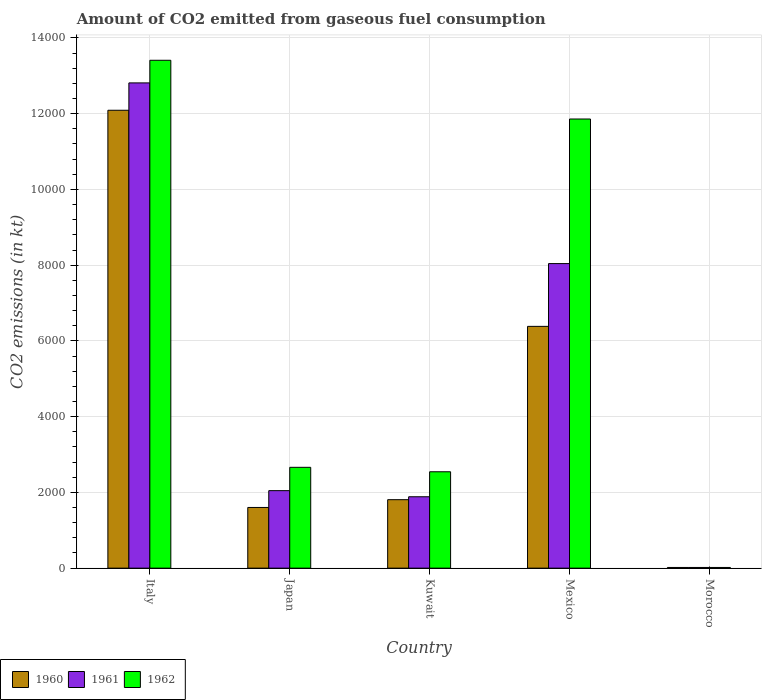How many groups of bars are there?
Keep it short and to the point. 5. Are the number of bars per tick equal to the number of legend labels?
Offer a terse response. Yes. How many bars are there on the 3rd tick from the right?
Give a very brief answer. 3. What is the label of the 1st group of bars from the left?
Make the answer very short. Italy. In how many cases, is the number of bars for a given country not equal to the number of legend labels?
Offer a very short reply. 0. What is the amount of CO2 emitted in 1962 in Kuwait?
Give a very brief answer. 2544.9. Across all countries, what is the maximum amount of CO2 emitted in 1960?
Ensure brevity in your answer.  1.21e+04. Across all countries, what is the minimum amount of CO2 emitted in 1962?
Provide a succinct answer. 18.34. In which country was the amount of CO2 emitted in 1960 minimum?
Keep it short and to the point. Morocco. What is the total amount of CO2 emitted in 1962 in the graph?
Offer a very short reply. 3.05e+04. What is the difference between the amount of CO2 emitted in 1962 in Kuwait and that in Mexico?
Offer a terse response. -9314.18. What is the difference between the amount of CO2 emitted in 1961 in Mexico and the amount of CO2 emitted in 1962 in Morocco?
Your answer should be very brief. 8023.4. What is the average amount of CO2 emitted in 1962 per country?
Provide a succinct answer. 6098.95. What is the difference between the amount of CO2 emitted of/in 1962 and amount of CO2 emitted of/in 1961 in Mexico?
Your answer should be compact. 3817.35. What is the ratio of the amount of CO2 emitted in 1960 in Italy to that in Japan?
Offer a very short reply. 7.54. Is the amount of CO2 emitted in 1960 in Kuwait less than that in Mexico?
Your answer should be compact. Yes. Is the difference between the amount of CO2 emitted in 1962 in Kuwait and Mexico greater than the difference between the amount of CO2 emitted in 1961 in Kuwait and Mexico?
Give a very brief answer. No. What is the difference between the highest and the second highest amount of CO2 emitted in 1960?
Ensure brevity in your answer.  -5705.85. What is the difference between the highest and the lowest amount of CO2 emitted in 1962?
Offer a terse response. 1.34e+04. What does the 3rd bar from the left in Mexico represents?
Offer a terse response. 1962. Is it the case that in every country, the sum of the amount of CO2 emitted in 1962 and amount of CO2 emitted in 1961 is greater than the amount of CO2 emitted in 1960?
Offer a very short reply. Yes. Are the values on the major ticks of Y-axis written in scientific E-notation?
Ensure brevity in your answer.  No. Does the graph contain any zero values?
Give a very brief answer. No. How many legend labels are there?
Ensure brevity in your answer.  3. How are the legend labels stacked?
Your answer should be compact. Horizontal. What is the title of the graph?
Provide a succinct answer. Amount of CO2 emitted from gaseous fuel consumption. Does "1997" appear as one of the legend labels in the graph?
Provide a short and direct response. No. What is the label or title of the X-axis?
Your response must be concise. Country. What is the label or title of the Y-axis?
Provide a succinct answer. CO2 emissions (in kt). What is the CO2 emissions (in kt) in 1960 in Italy?
Provide a short and direct response. 1.21e+04. What is the CO2 emissions (in kt) in 1961 in Italy?
Your answer should be very brief. 1.28e+04. What is the CO2 emissions (in kt) in 1962 in Italy?
Your answer should be very brief. 1.34e+04. What is the CO2 emissions (in kt) of 1960 in Japan?
Ensure brevity in your answer.  1602.48. What is the CO2 emissions (in kt) of 1961 in Japan?
Offer a terse response. 2046.19. What is the CO2 emissions (in kt) of 1962 in Japan?
Offer a terse response. 2662.24. What is the CO2 emissions (in kt) of 1960 in Kuwait?
Give a very brief answer. 1807.83. What is the CO2 emissions (in kt) of 1961 in Kuwait?
Your response must be concise. 1884.84. What is the CO2 emissions (in kt) of 1962 in Kuwait?
Your answer should be very brief. 2544.9. What is the CO2 emissions (in kt) of 1960 in Mexico?
Provide a succinct answer. 6384.25. What is the CO2 emissions (in kt) of 1961 in Mexico?
Keep it short and to the point. 8041.73. What is the CO2 emissions (in kt) of 1962 in Mexico?
Your answer should be compact. 1.19e+04. What is the CO2 emissions (in kt) in 1960 in Morocco?
Offer a terse response. 18.34. What is the CO2 emissions (in kt) in 1961 in Morocco?
Provide a short and direct response. 18.34. What is the CO2 emissions (in kt) of 1962 in Morocco?
Provide a short and direct response. 18.34. Across all countries, what is the maximum CO2 emissions (in kt) in 1960?
Provide a succinct answer. 1.21e+04. Across all countries, what is the maximum CO2 emissions (in kt) of 1961?
Your answer should be very brief. 1.28e+04. Across all countries, what is the maximum CO2 emissions (in kt) in 1962?
Your answer should be compact. 1.34e+04. Across all countries, what is the minimum CO2 emissions (in kt) of 1960?
Keep it short and to the point. 18.34. Across all countries, what is the minimum CO2 emissions (in kt) in 1961?
Your answer should be compact. 18.34. Across all countries, what is the minimum CO2 emissions (in kt) in 1962?
Provide a succinct answer. 18.34. What is the total CO2 emissions (in kt) in 1960 in the graph?
Your answer should be compact. 2.19e+04. What is the total CO2 emissions (in kt) of 1961 in the graph?
Provide a short and direct response. 2.48e+04. What is the total CO2 emissions (in kt) in 1962 in the graph?
Your answer should be very brief. 3.05e+04. What is the difference between the CO2 emissions (in kt) in 1960 in Italy and that in Japan?
Offer a very short reply. 1.05e+04. What is the difference between the CO2 emissions (in kt) in 1961 in Italy and that in Japan?
Offer a very short reply. 1.08e+04. What is the difference between the CO2 emissions (in kt) in 1962 in Italy and that in Japan?
Ensure brevity in your answer.  1.07e+04. What is the difference between the CO2 emissions (in kt) in 1960 in Italy and that in Kuwait?
Make the answer very short. 1.03e+04. What is the difference between the CO2 emissions (in kt) of 1961 in Italy and that in Kuwait?
Keep it short and to the point. 1.09e+04. What is the difference between the CO2 emissions (in kt) in 1962 in Italy and that in Kuwait?
Provide a short and direct response. 1.09e+04. What is the difference between the CO2 emissions (in kt) in 1960 in Italy and that in Mexico?
Ensure brevity in your answer.  5705.85. What is the difference between the CO2 emissions (in kt) in 1961 in Italy and that in Mexico?
Your response must be concise. 4770.77. What is the difference between the CO2 emissions (in kt) in 1962 in Italy and that in Mexico?
Your response must be concise. 1551.14. What is the difference between the CO2 emissions (in kt) of 1960 in Italy and that in Morocco?
Make the answer very short. 1.21e+04. What is the difference between the CO2 emissions (in kt) in 1961 in Italy and that in Morocco?
Your answer should be compact. 1.28e+04. What is the difference between the CO2 emissions (in kt) of 1962 in Italy and that in Morocco?
Give a very brief answer. 1.34e+04. What is the difference between the CO2 emissions (in kt) of 1960 in Japan and that in Kuwait?
Offer a terse response. -205.35. What is the difference between the CO2 emissions (in kt) in 1961 in Japan and that in Kuwait?
Keep it short and to the point. 161.35. What is the difference between the CO2 emissions (in kt) in 1962 in Japan and that in Kuwait?
Make the answer very short. 117.34. What is the difference between the CO2 emissions (in kt) in 1960 in Japan and that in Mexico?
Offer a very short reply. -4781.77. What is the difference between the CO2 emissions (in kt) in 1961 in Japan and that in Mexico?
Provide a short and direct response. -5995.55. What is the difference between the CO2 emissions (in kt) in 1962 in Japan and that in Mexico?
Give a very brief answer. -9196.84. What is the difference between the CO2 emissions (in kt) of 1960 in Japan and that in Morocco?
Offer a very short reply. 1584.14. What is the difference between the CO2 emissions (in kt) in 1961 in Japan and that in Morocco?
Offer a very short reply. 2027.85. What is the difference between the CO2 emissions (in kt) in 1962 in Japan and that in Morocco?
Provide a succinct answer. 2643.91. What is the difference between the CO2 emissions (in kt) in 1960 in Kuwait and that in Mexico?
Keep it short and to the point. -4576.42. What is the difference between the CO2 emissions (in kt) in 1961 in Kuwait and that in Mexico?
Your response must be concise. -6156.89. What is the difference between the CO2 emissions (in kt) in 1962 in Kuwait and that in Mexico?
Your answer should be compact. -9314.18. What is the difference between the CO2 emissions (in kt) in 1960 in Kuwait and that in Morocco?
Provide a succinct answer. 1789.5. What is the difference between the CO2 emissions (in kt) of 1961 in Kuwait and that in Morocco?
Offer a terse response. 1866.5. What is the difference between the CO2 emissions (in kt) in 1962 in Kuwait and that in Morocco?
Offer a very short reply. 2526.56. What is the difference between the CO2 emissions (in kt) of 1960 in Mexico and that in Morocco?
Your response must be concise. 6365.91. What is the difference between the CO2 emissions (in kt) in 1961 in Mexico and that in Morocco?
Your answer should be very brief. 8023.4. What is the difference between the CO2 emissions (in kt) in 1962 in Mexico and that in Morocco?
Make the answer very short. 1.18e+04. What is the difference between the CO2 emissions (in kt) of 1960 in Italy and the CO2 emissions (in kt) of 1961 in Japan?
Your response must be concise. 1.00e+04. What is the difference between the CO2 emissions (in kt) of 1960 in Italy and the CO2 emissions (in kt) of 1962 in Japan?
Offer a very short reply. 9427.86. What is the difference between the CO2 emissions (in kt) in 1961 in Italy and the CO2 emissions (in kt) in 1962 in Japan?
Provide a short and direct response. 1.02e+04. What is the difference between the CO2 emissions (in kt) in 1960 in Italy and the CO2 emissions (in kt) in 1961 in Kuwait?
Offer a very short reply. 1.02e+04. What is the difference between the CO2 emissions (in kt) in 1960 in Italy and the CO2 emissions (in kt) in 1962 in Kuwait?
Keep it short and to the point. 9545.2. What is the difference between the CO2 emissions (in kt) in 1961 in Italy and the CO2 emissions (in kt) in 1962 in Kuwait?
Your answer should be compact. 1.03e+04. What is the difference between the CO2 emissions (in kt) in 1960 in Italy and the CO2 emissions (in kt) in 1961 in Mexico?
Ensure brevity in your answer.  4048.37. What is the difference between the CO2 emissions (in kt) in 1960 in Italy and the CO2 emissions (in kt) in 1962 in Mexico?
Your response must be concise. 231.02. What is the difference between the CO2 emissions (in kt) of 1961 in Italy and the CO2 emissions (in kt) of 1962 in Mexico?
Your answer should be very brief. 953.42. What is the difference between the CO2 emissions (in kt) in 1960 in Italy and the CO2 emissions (in kt) in 1961 in Morocco?
Offer a very short reply. 1.21e+04. What is the difference between the CO2 emissions (in kt) of 1960 in Italy and the CO2 emissions (in kt) of 1962 in Morocco?
Your response must be concise. 1.21e+04. What is the difference between the CO2 emissions (in kt) in 1961 in Italy and the CO2 emissions (in kt) in 1962 in Morocco?
Make the answer very short. 1.28e+04. What is the difference between the CO2 emissions (in kt) in 1960 in Japan and the CO2 emissions (in kt) in 1961 in Kuwait?
Your answer should be very brief. -282.36. What is the difference between the CO2 emissions (in kt) of 1960 in Japan and the CO2 emissions (in kt) of 1962 in Kuwait?
Ensure brevity in your answer.  -942.42. What is the difference between the CO2 emissions (in kt) in 1961 in Japan and the CO2 emissions (in kt) in 1962 in Kuwait?
Provide a short and direct response. -498.71. What is the difference between the CO2 emissions (in kt) of 1960 in Japan and the CO2 emissions (in kt) of 1961 in Mexico?
Give a very brief answer. -6439.25. What is the difference between the CO2 emissions (in kt) of 1960 in Japan and the CO2 emissions (in kt) of 1962 in Mexico?
Ensure brevity in your answer.  -1.03e+04. What is the difference between the CO2 emissions (in kt) of 1961 in Japan and the CO2 emissions (in kt) of 1962 in Mexico?
Your answer should be compact. -9812.89. What is the difference between the CO2 emissions (in kt) in 1960 in Japan and the CO2 emissions (in kt) in 1961 in Morocco?
Provide a short and direct response. 1584.14. What is the difference between the CO2 emissions (in kt) in 1960 in Japan and the CO2 emissions (in kt) in 1962 in Morocco?
Your answer should be very brief. 1584.14. What is the difference between the CO2 emissions (in kt) in 1961 in Japan and the CO2 emissions (in kt) in 1962 in Morocco?
Your response must be concise. 2027.85. What is the difference between the CO2 emissions (in kt) in 1960 in Kuwait and the CO2 emissions (in kt) in 1961 in Mexico?
Your answer should be very brief. -6233.9. What is the difference between the CO2 emissions (in kt) in 1960 in Kuwait and the CO2 emissions (in kt) in 1962 in Mexico?
Make the answer very short. -1.01e+04. What is the difference between the CO2 emissions (in kt) of 1961 in Kuwait and the CO2 emissions (in kt) of 1962 in Mexico?
Give a very brief answer. -9974.24. What is the difference between the CO2 emissions (in kt) in 1960 in Kuwait and the CO2 emissions (in kt) in 1961 in Morocco?
Offer a terse response. 1789.5. What is the difference between the CO2 emissions (in kt) in 1960 in Kuwait and the CO2 emissions (in kt) in 1962 in Morocco?
Give a very brief answer. 1789.5. What is the difference between the CO2 emissions (in kt) of 1961 in Kuwait and the CO2 emissions (in kt) of 1962 in Morocco?
Your answer should be very brief. 1866.5. What is the difference between the CO2 emissions (in kt) of 1960 in Mexico and the CO2 emissions (in kt) of 1961 in Morocco?
Your response must be concise. 6365.91. What is the difference between the CO2 emissions (in kt) of 1960 in Mexico and the CO2 emissions (in kt) of 1962 in Morocco?
Your response must be concise. 6365.91. What is the difference between the CO2 emissions (in kt) of 1961 in Mexico and the CO2 emissions (in kt) of 1962 in Morocco?
Make the answer very short. 8023.4. What is the average CO2 emissions (in kt) in 1960 per country?
Keep it short and to the point. 4380.6. What is the average CO2 emissions (in kt) of 1961 per country?
Offer a terse response. 4960.72. What is the average CO2 emissions (in kt) of 1962 per country?
Ensure brevity in your answer.  6098.95. What is the difference between the CO2 emissions (in kt) of 1960 and CO2 emissions (in kt) of 1961 in Italy?
Keep it short and to the point. -722.4. What is the difference between the CO2 emissions (in kt) of 1960 and CO2 emissions (in kt) of 1962 in Italy?
Offer a very short reply. -1320.12. What is the difference between the CO2 emissions (in kt) of 1961 and CO2 emissions (in kt) of 1962 in Italy?
Your answer should be compact. -597.72. What is the difference between the CO2 emissions (in kt) of 1960 and CO2 emissions (in kt) of 1961 in Japan?
Your answer should be very brief. -443.71. What is the difference between the CO2 emissions (in kt) in 1960 and CO2 emissions (in kt) in 1962 in Japan?
Your answer should be compact. -1059.76. What is the difference between the CO2 emissions (in kt) in 1961 and CO2 emissions (in kt) in 1962 in Japan?
Your response must be concise. -616.06. What is the difference between the CO2 emissions (in kt) in 1960 and CO2 emissions (in kt) in 1961 in Kuwait?
Provide a short and direct response. -77.01. What is the difference between the CO2 emissions (in kt) in 1960 and CO2 emissions (in kt) in 1962 in Kuwait?
Offer a very short reply. -737.07. What is the difference between the CO2 emissions (in kt) of 1961 and CO2 emissions (in kt) of 1962 in Kuwait?
Offer a terse response. -660.06. What is the difference between the CO2 emissions (in kt) in 1960 and CO2 emissions (in kt) in 1961 in Mexico?
Your response must be concise. -1657.48. What is the difference between the CO2 emissions (in kt) of 1960 and CO2 emissions (in kt) of 1962 in Mexico?
Your answer should be compact. -5474.83. What is the difference between the CO2 emissions (in kt) of 1961 and CO2 emissions (in kt) of 1962 in Mexico?
Make the answer very short. -3817.35. What is the difference between the CO2 emissions (in kt) in 1960 and CO2 emissions (in kt) in 1961 in Morocco?
Keep it short and to the point. 0. What is the difference between the CO2 emissions (in kt) of 1960 and CO2 emissions (in kt) of 1962 in Morocco?
Provide a succinct answer. 0. What is the difference between the CO2 emissions (in kt) of 1961 and CO2 emissions (in kt) of 1962 in Morocco?
Ensure brevity in your answer.  0. What is the ratio of the CO2 emissions (in kt) in 1960 in Italy to that in Japan?
Your answer should be compact. 7.54. What is the ratio of the CO2 emissions (in kt) of 1961 in Italy to that in Japan?
Make the answer very short. 6.26. What is the ratio of the CO2 emissions (in kt) in 1962 in Italy to that in Japan?
Keep it short and to the point. 5.04. What is the ratio of the CO2 emissions (in kt) of 1960 in Italy to that in Kuwait?
Keep it short and to the point. 6.69. What is the ratio of the CO2 emissions (in kt) of 1961 in Italy to that in Kuwait?
Provide a short and direct response. 6.8. What is the ratio of the CO2 emissions (in kt) of 1962 in Italy to that in Kuwait?
Provide a succinct answer. 5.27. What is the ratio of the CO2 emissions (in kt) in 1960 in Italy to that in Mexico?
Your answer should be very brief. 1.89. What is the ratio of the CO2 emissions (in kt) of 1961 in Italy to that in Mexico?
Offer a terse response. 1.59. What is the ratio of the CO2 emissions (in kt) of 1962 in Italy to that in Mexico?
Provide a short and direct response. 1.13. What is the ratio of the CO2 emissions (in kt) of 1960 in Italy to that in Morocco?
Keep it short and to the point. 659.4. What is the ratio of the CO2 emissions (in kt) in 1961 in Italy to that in Morocco?
Your answer should be compact. 698.8. What is the ratio of the CO2 emissions (in kt) in 1962 in Italy to that in Morocco?
Provide a short and direct response. 731.4. What is the ratio of the CO2 emissions (in kt) of 1960 in Japan to that in Kuwait?
Your answer should be very brief. 0.89. What is the ratio of the CO2 emissions (in kt) in 1961 in Japan to that in Kuwait?
Keep it short and to the point. 1.09. What is the ratio of the CO2 emissions (in kt) in 1962 in Japan to that in Kuwait?
Your response must be concise. 1.05. What is the ratio of the CO2 emissions (in kt) in 1960 in Japan to that in Mexico?
Ensure brevity in your answer.  0.25. What is the ratio of the CO2 emissions (in kt) in 1961 in Japan to that in Mexico?
Your answer should be very brief. 0.25. What is the ratio of the CO2 emissions (in kt) in 1962 in Japan to that in Mexico?
Make the answer very short. 0.22. What is the ratio of the CO2 emissions (in kt) in 1960 in Japan to that in Morocco?
Ensure brevity in your answer.  87.4. What is the ratio of the CO2 emissions (in kt) in 1961 in Japan to that in Morocco?
Your response must be concise. 111.6. What is the ratio of the CO2 emissions (in kt) in 1962 in Japan to that in Morocco?
Your response must be concise. 145.2. What is the ratio of the CO2 emissions (in kt) in 1960 in Kuwait to that in Mexico?
Provide a succinct answer. 0.28. What is the ratio of the CO2 emissions (in kt) in 1961 in Kuwait to that in Mexico?
Your answer should be compact. 0.23. What is the ratio of the CO2 emissions (in kt) in 1962 in Kuwait to that in Mexico?
Provide a succinct answer. 0.21. What is the ratio of the CO2 emissions (in kt) of 1960 in Kuwait to that in Morocco?
Provide a short and direct response. 98.6. What is the ratio of the CO2 emissions (in kt) in 1961 in Kuwait to that in Morocco?
Keep it short and to the point. 102.8. What is the ratio of the CO2 emissions (in kt) in 1962 in Kuwait to that in Morocco?
Offer a very short reply. 138.8. What is the ratio of the CO2 emissions (in kt) in 1960 in Mexico to that in Morocco?
Ensure brevity in your answer.  348.2. What is the ratio of the CO2 emissions (in kt) of 1961 in Mexico to that in Morocco?
Your response must be concise. 438.6. What is the ratio of the CO2 emissions (in kt) of 1962 in Mexico to that in Morocco?
Provide a succinct answer. 646.8. What is the difference between the highest and the second highest CO2 emissions (in kt) of 1960?
Your answer should be very brief. 5705.85. What is the difference between the highest and the second highest CO2 emissions (in kt) in 1961?
Offer a terse response. 4770.77. What is the difference between the highest and the second highest CO2 emissions (in kt) in 1962?
Your answer should be compact. 1551.14. What is the difference between the highest and the lowest CO2 emissions (in kt) in 1960?
Provide a short and direct response. 1.21e+04. What is the difference between the highest and the lowest CO2 emissions (in kt) in 1961?
Make the answer very short. 1.28e+04. What is the difference between the highest and the lowest CO2 emissions (in kt) of 1962?
Ensure brevity in your answer.  1.34e+04. 